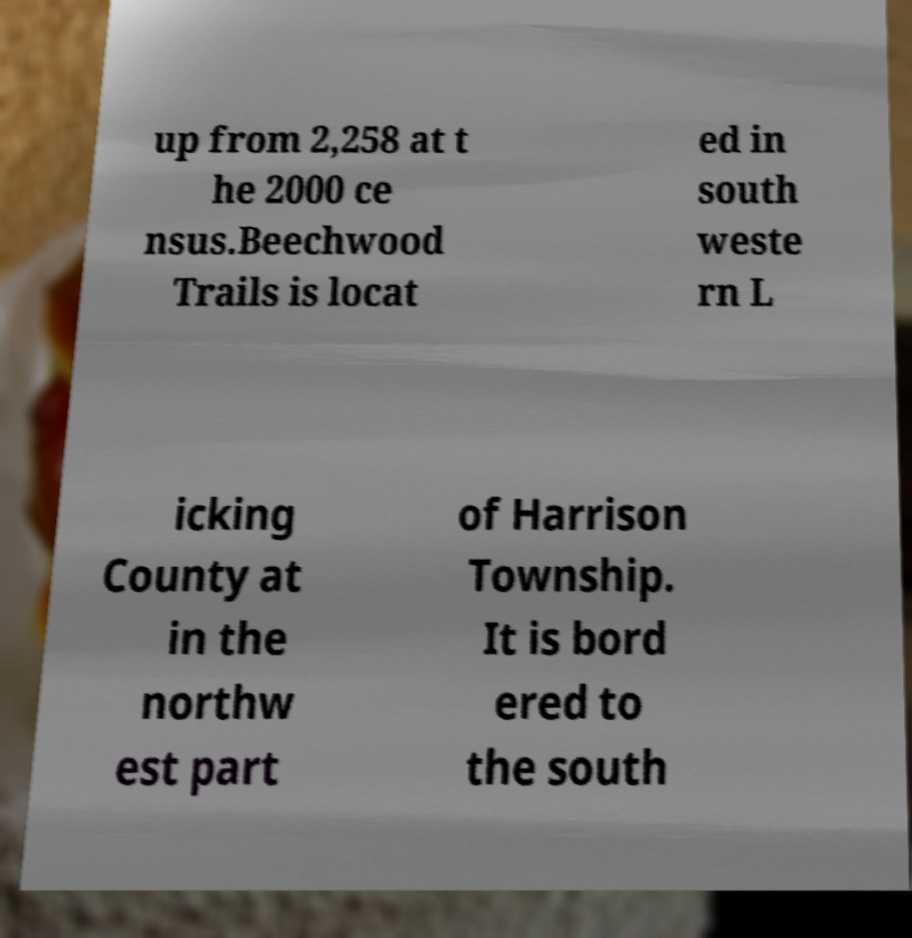Please identify and transcribe the text found in this image. up from 2,258 at t he 2000 ce nsus.Beechwood Trails is locat ed in south weste rn L icking County at in the northw est part of Harrison Township. It is bord ered to the south 